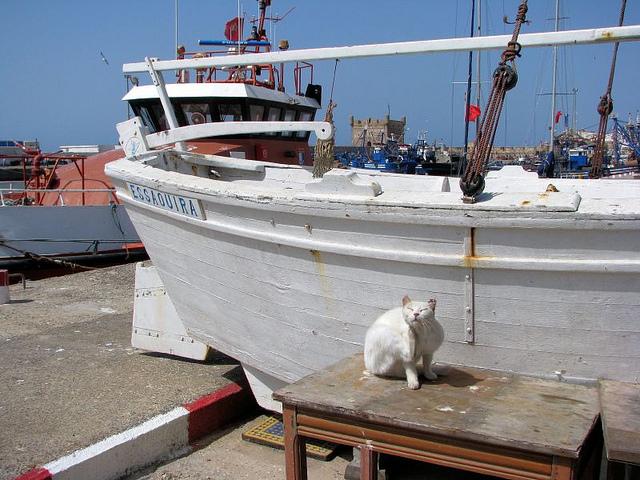What is the cat sitting on?
Keep it brief. Table. What is the name of the boat?
Be succinct. Essaquira. Is this cat going boating?
Give a very brief answer. No. 